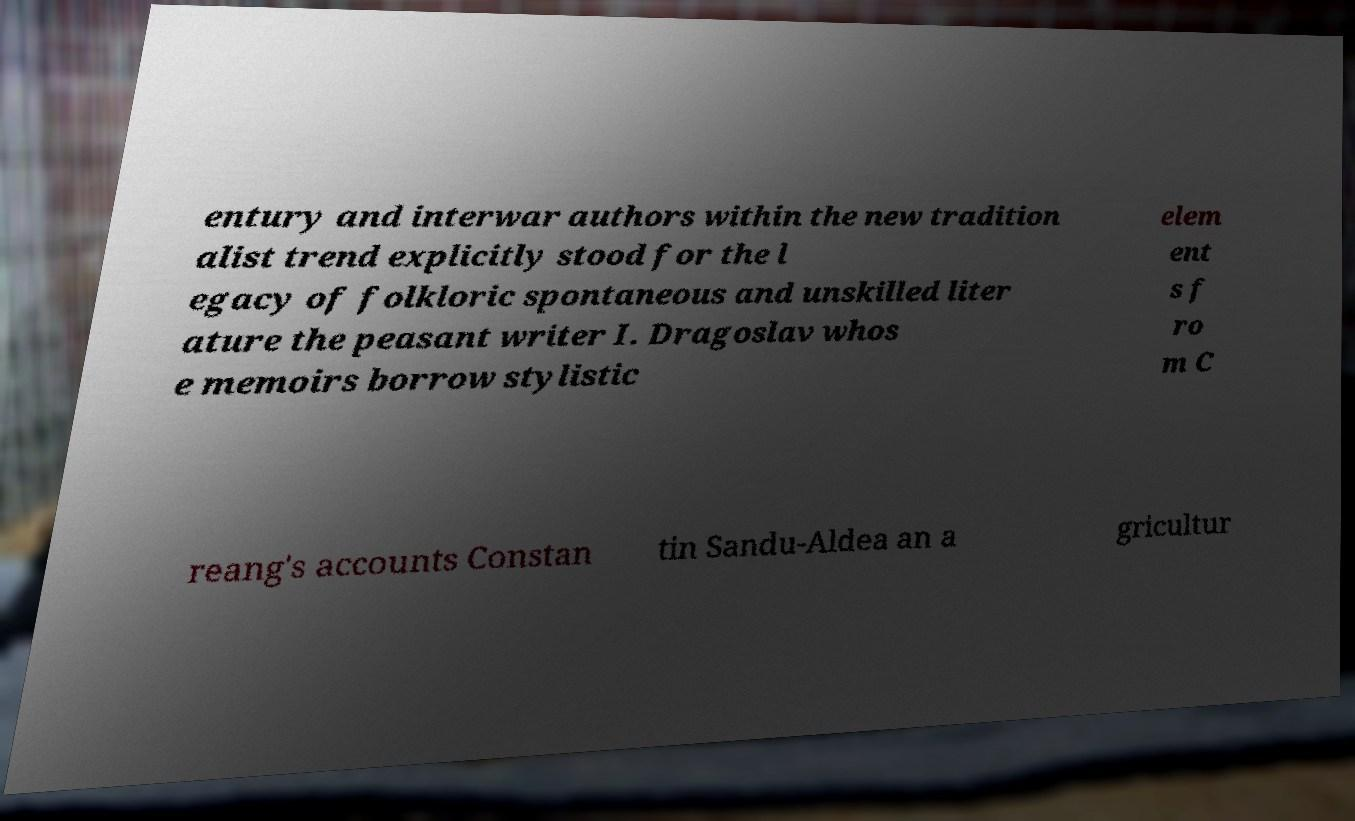For documentation purposes, I need the text within this image transcribed. Could you provide that? entury and interwar authors within the new tradition alist trend explicitly stood for the l egacy of folkloric spontaneous and unskilled liter ature the peasant writer I. Dragoslav whos e memoirs borrow stylistic elem ent s f ro m C reang's accounts Constan tin Sandu-Aldea an a gricultur 